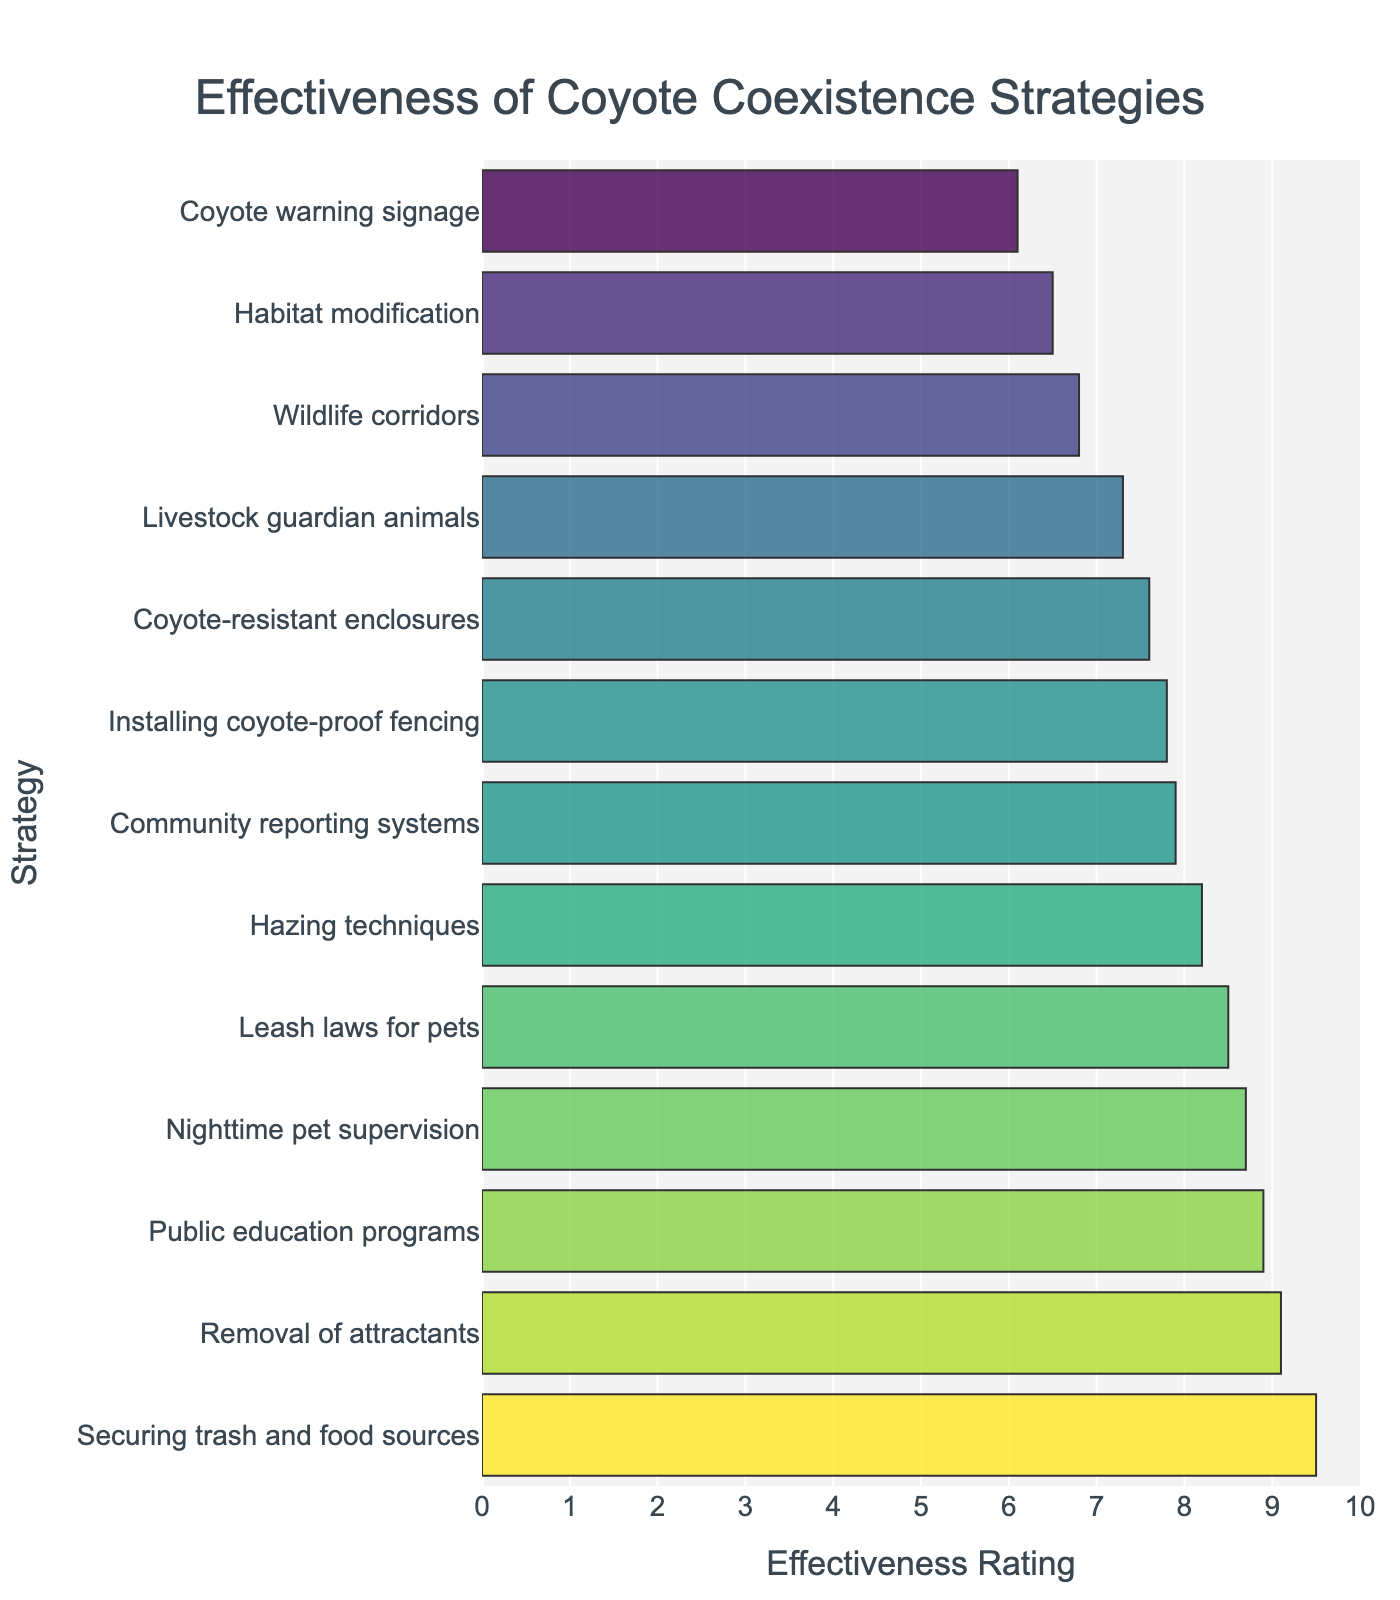Which strategy has the highest effectiveness rating? Identify the tallest bar in the plot. The bar representing "Securing trash and food sources" is the highest.
Answer: Securing trash and food sources Which two strategies have an effectiveness rating greater than 9? Identify the bars in the plot that have a value above 9 on the x-axis. The bars for "Securing trash and food sources" and "Removal of attractants" meet this criterion.
Answer: Securing trash and food sources, Removal of attractants What is the difference in effectiveness rating between the highest and lowest rated strategies? The highest effectiveness rating is 9.5 for "Securing trash and food sources," and the lowest is 6.1 for "Coyote warning signage." The difference is 9.5 - 6.1.
Answer: 3.4 What is the average effectiveness rating of strategies with ratings above 8? Identify the strategies with ratings above 8: Hazing techniques (8.2), Securing trash and food sources (9.5), Public education programs (8.9), Removal of attractants (9.1), Leash laws for pets (8.5), Nighttime pet supervision (8.7). Sum these ratings and divide by the number of strategies: (8.2 + 9.5 + 8.9 + 9.1 + 8.5 + 8.7) / 6.
Answer: 8.82 Which strategy has a slightly higher effectiveness rating: "Community reporting systems" or "Installing coyote-proof fencing"? Compare the heights of bars for "Community reporting systems" (7.9) and "Installing coyote-proof fencing" (7.8).
Answer: Community reporting systems What is the median effectiveness rating of all strategies? Order all effectiveness ratings: 6.1, 6.5, 6.8, 7.3, 7.6, 7.8, 7.9, 8.2, 8.5, 8.7, 8.9, 9.1, 9.5. The middle value is the median, which is the 7th value in this ordered set.
Answer: 7.9 How many strategies have an effectiveness rating below 7? Count the bars with values less than 7: Habitat modification (6.5), Coyote warning signage (6.1), Wildlife corridors (6.8).
Answer: 3 Which has a greater difference in effectiveness rating: "Livestock guardian animals" and "Leash laws for pets" or "Hazing techniques" and "Coyote warning signage"? Calculate the differences: Livestock guardian animals (7.3) and Leash laws for pets (8.5) differ by 8.5 - 7.3 = 1.2. Hazing techniques (8.2) and Coyote warning signage (6.1) differ by 8.2 - 6.1 = 2.1.
Answer: Hazing techniques and Coyote warning signage How does the effectiveness rating of "Wildlife corridors" compare to that of "Habitat modification"? Compare the effectiveness ratings: Wildlife corridors is 6.8 and Habitat modification is 6.5.
Answer: Wildlife corridors is higher Among the top five highest-rated strategies, which one is rated lowest? Identify the top five highest bars, which are: Securing trash and food sources (9.5), Removal of attractants (9.1), Public education programs (8.9), Nighttime pet supervision (8.7), and Leash laws for pets (8.5). Determine the lowest value among these.
Answer: Leash laws for pets 